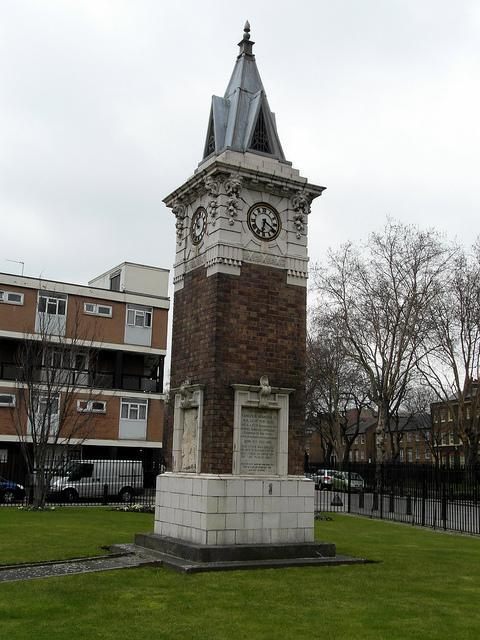What color are the square bricks outlining the base of this small clock tower? white 